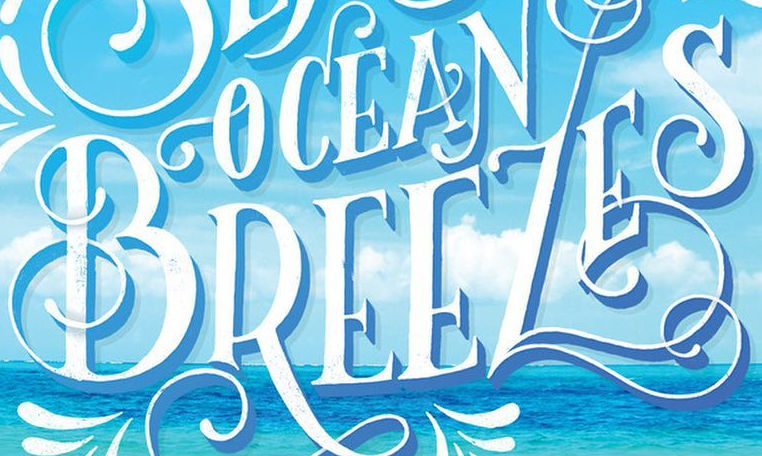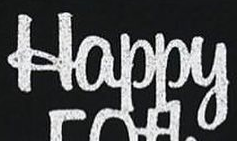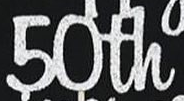What text is displayed in these images sequentially, separated by a semicolon? BREEZES; Happy; 50th 